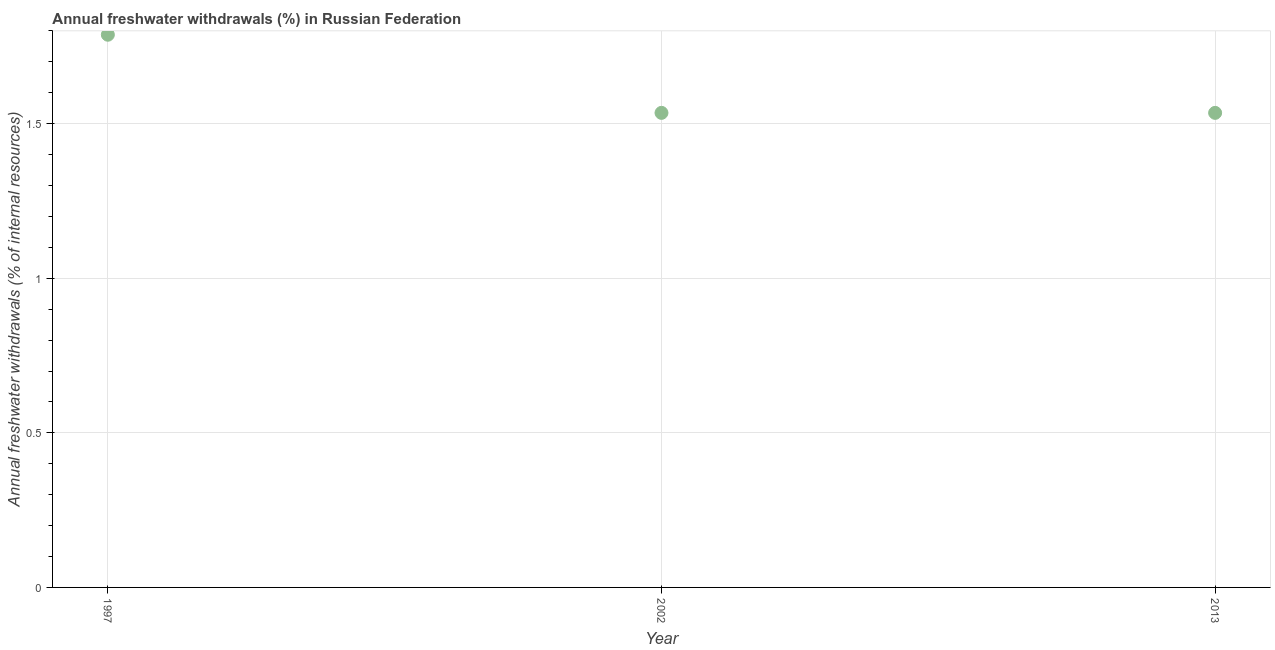What is the annual freshwater withdrawals in 2002?
Your answer should be very brief. 1.53. Across all years, what is the maximum annual freshwater withdrawals?
Your answer should be very brief. 1.79. Across all years, what is the minimum annual freshwater withdrawals?
Your answer should be compact. 1.53. In which year was the annual freshwater withdrawals maximum?
Keep it short and to the point. 1997. In which year was the annual freshwater withdrawals minimum?
Ensure brevity in your answer.  2002. What is the sum of the annual freshwater withdrawals?
Your answer should be compact. 4.86. What is the average annual freshwater withdrawals per year?
Give a very brief answer. 1.62. What is the median annual freshwater withdrawals?
Provide a short and direct response. 1.53. In how many years, is the annual freshwater withdrawals greater than 0.7 %?
Your answer should be very brief. 3. Do a majority of the years between 1997 and 2013 (inclusive) have annual freshwater withdrawals greater than 1.7 %?
Your answer should be very brief. No. What is the ratio of the annual freshwater withdrawals in 1997 to that in 2002?
Keep it short and to the point. 1.16. Is the annual freshwater withdrawals in 1997 less than that in 2002?
Offer a terse response. No. What is the difference between the highest and the second highest annual freshwater withdrawals?
Make the answer very short. 0.25. What is the difference between the highest and the lowest annual freshwater withdrawals?
Offer a very short reply. 0.25. Does the annual freshwater withdrawals monotonically increase over the years?
Provide a short and direct response. No. How many years are there in the graph?
Offer a terse response. 3. What is the difference between two consecutive major ticks on the Y-axis?
Your answer should be compact. 0.5. Are the values on the major ticks of Y-axis written in scientific E-notation?
Your response must be concise. No. Does the graph contain any zero values?
Provide a short and direct response. No. Does the graph contain grids?
Ensure brevity in your answer.  Yes. What is the title of the graph?
Keep it short and to the point. Annual freshwater withdrawals (%) in Russian Federation. What is the label or title of the Y-axis?
Make the answer very short. Annual freshwater withdrawals (% of internal resources). What is the Annual freshwater withdrawals (% of internal resources) in 1997?
Provide a succinct answer. 1.79. What is the Annual freshwater withdrawals (% of internal resources) in 2002?
Ensure brevity in your answer.  1.53. What is the Annual freshwater withdrawals (% of internal resources) in 2013?
Provide a short and direct response. 1.53. What is the difference between the Annual freshwater withdrawals (% of internal resources) in 1997 and 2002?
Provide a succinct answer. 0.25. What is the difference between the Annual freshwater withdrawals (% of internal resources) in 1997 and 2013?
Offer a terse response. 0.25. What is the ratio of the Annual freshwater withdrawals (% of internal resources) in 1997 to that in 2002?
Provide a short and direct response. 1.17. What is the ratio of the Annual freshwater withdrawals (% of internal resources) in 1997 to that in 2013?
Your response must be concise. 1.17. 